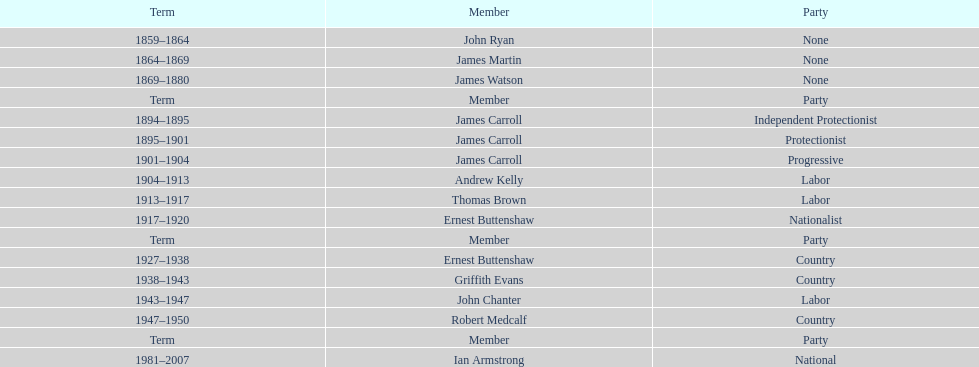Which member of the second incarnation of the lachlan was also a nationalist? Ernest Buttenshaw. 